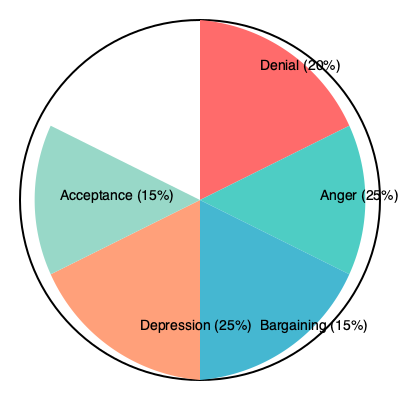As a hospice chaplain, you encounter various manifestations of grief among patients and their families. The pie chart above represents the distribution of time individuals typically spend in each stage of grief according to the Kübler-Ross model. Based on this visualization, which two stages combined account for half of the grieving process, and how might this information guide your approach to spiritual counseling? To answer this question, we need to analyze the pie chart and interpret its implications for spiritual counseling:

1. Identify the stages and their percentages:
   - Denial: 20%
   - Anger: 25%
   - Bargaining: 15%
   - Depression: 25%
   - Acceptance: 15%

2. Determine which two stages combined account for 50%:
   - Anger (25%) + Depression (25%) = 50%

3. Interpret the implications for spiritual counseling:
   a) Recognition: Understand that anger and depression are the most time-consuming stages, accounting for half of the grieving process.
   
   b) Validation: Acknowledge that these intense emotions are normal and significant parts of the grieving journey.
   
   c) Support: Develop strategies to help individuals navigate through anger and depression, such as:
      - For anger: Encourage healthy expression of emotions, practice forgiveness, and find constructive outlets.
      - For depression: Promote self-care, offer hope, and explore spiritual practices that bring comfort.
   
   d) Balance: While focusing on anger and depression, don't neglect the other stages. Be prepared to address denial, bargaining, and acceptance as well.
   
   e) Individualization: Remember that this chart represents averages, and each person's grief journey is unique. Tailor your approach to each individual's needs and experiences.
   
   f) Transition support: Develop techniques to help individuals move from anger and depression towards acceptance, recognizing that this transition may be challenging but crucial for healing.

By understanding the prominence of anger and depression in the grieving process, a hospice chaplain can better allocate time and resources, and develop more targeted spiritual support strategies to guide individuals through these particularly challenging stages while remaining attentive to the entire grief journey.
Answer: Anger and Depression; focus on validating emotions, providing tailored support for these stages while addressing all aspects of grief. 